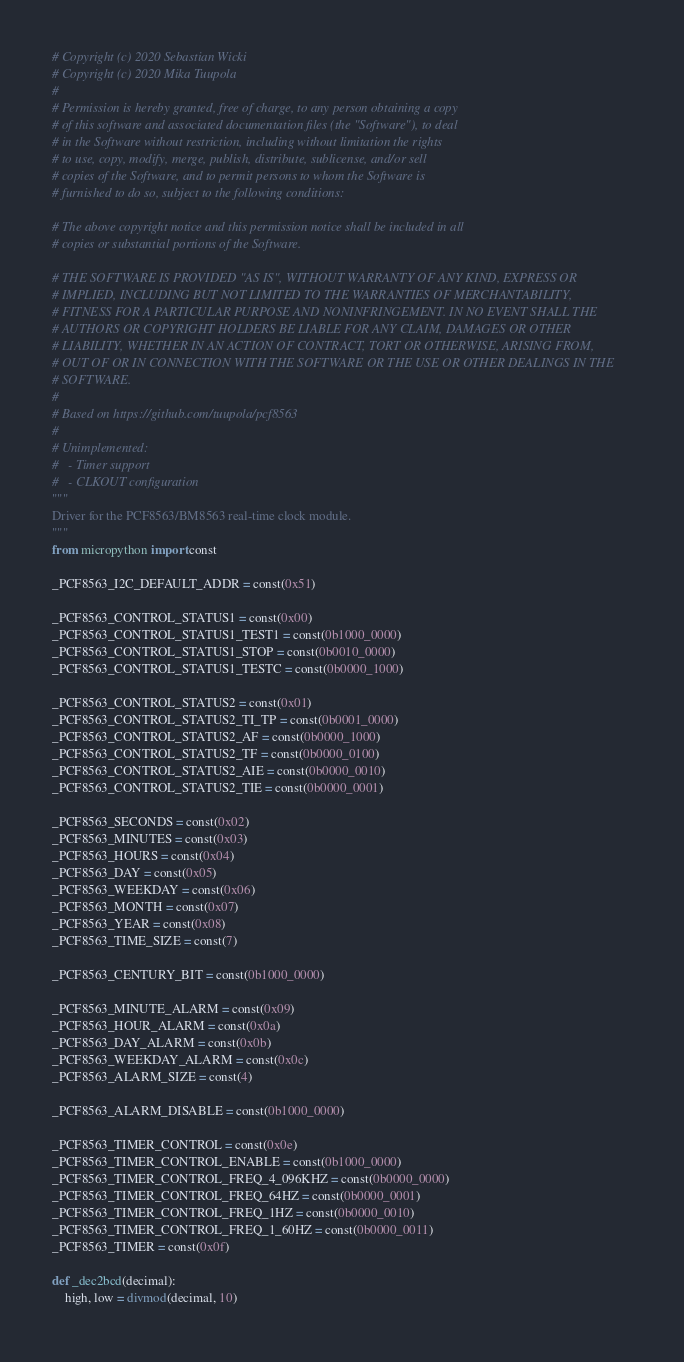<code> <loc_0><loc_0><loc_500><loc_500><_Python_># Copyright (c) 2020 Sebastian Wicki
# Copyright (c) 2020 Mika Tuupola
#
# Permission is hereby granted, free of charge, to any person obtaining a copy
# of this software and associated documentation files (the "Software"), to deal
# in the Software without restriction, including without limitation the rights
# to use, copy, modify, merge, publish, distribute, sublicense, and/or sell
# copies of the Software, and to permit persons to whom the Software is
# furnished to do so, subject to the following conditions:

# The above copyright notice and this permission notice shall be included in all
# copies or substantial portions of the Software.

# THE SOFTWARE IS PROVIDED "AS IS", WITHOUT WARRANTY OF ANY KIND, EXPRESS OR
# IMPLIED, INCLUDING BUT NOT LIMITED TO THE WARRANTIES OF MERCHANTABILITY,
# FITNESS FOR A PARTICULAR PURPOSE AND NONINFRINGEMENT. IN NO EVENT SHALL THE
# AUTHORS OR COPYRIGHT HOLDERS BE LIABLE FOR ANY CLAIM, DAMAGES OR OTHER
# LIABILITY, WHETHER IN AN ACTION OF CONTRACT, TORT OR OTHERWISE, ARISING FROM,
# OUT OF OR IN CONNECTION WITH THE SOFTWARE OR THE USE OR OTHER DEALINGS IN THE
# SOFTWARE.
#
# Based on https://github.com/tuupola/pcf8563
#
# Unimplemented:
#   - Timer support
#   - CLKOUT configuration
"""
Driver for the PCF8563/BM8563 real-time clock module.
"""
from micropython import const

_PCF8563_I2C_DEFAULT_ADDR = const(0x51)

_PCF8563_CONTROL_STATUS1 = const(0x00)
_PCF8563_CONTROL_STATUS1_TEST1 = const(0b1000_0000)
_PCF8563_CONTROL_STATUS1_STOP = const(0b0010_0000)
_PCF8563_CONTROL_STATUS1_TESTC = const(0b0000_1000)

_PCF8563_CONTROL_STATUS2 = const(0x01)
_PCF8563_CONTROL_STATUS2_TI_TP = const(0b0001_0000)
_PCF8563_CONTROL_STATUS2_AF = const(0b0000_1000)
_PCF8563_CONTROL_STATUS2_TF = const(0b0000_0100)
_PCF8563_CONTROL_STATUS2_AIE = const(0b0000_0010)
_PCF8563_CONTROL_STATUS2_TIE = const(0b0000_0001)

_PCF8563_SECONDS = const(0x02)
_PCF8563_MINUTES = const(0x03)
_PCF8563_HOURS = const(0x04)
_PCF8563_DAY = const(0x05)
_PCF8563_WEEKDAY = const(0x06)
_PCF8563_MONTH = const(0x07)
_PCF8563_YEAR = const(0x08)
_PCF8563_TIME_SIZE = const(7)

_PCF8563_CENTURY_BIT = const(0b1000_0000)

_PCF8563_MINUTE_ALARM = const(0x09)
_PCF8563_HOUR_ALARM = const(0x0a)
_PCF8563_DAY_ALARM = const(0x0b)
_PCF8563_WEEKDAY_ALARM = const(0x0c)
_PCF8563_ALARM_SIZE = const(4)

_PCF8563_ALARM_DISABLE = const(0b1000_0000)

_PCF8563_TIMER_CONTROL = const(0x0e)
_PCF8563_TIMER_CONTROL_ENABLE = const(0b1000_0000)
_PCF8563_TIMER_CONTROL_FREQ_4_096KHZ = const(0b0000_0000)
_PCF8563_TIMER_CONTROL_FREQ_64HZ = const(0b0000_0001)
_PCF8563_TIMER_CONTROL_FREQ_1HZ = const(0b0000_0010)
_PCF8563_TIMER_CONTROL_FREQ_1_60HZ = const(0b0000_0011)
_PCF8563_TIMER = const(0x0f)

def _dec2bcd(decimal):
    high, low = divmod(decimal, 10)</code> 